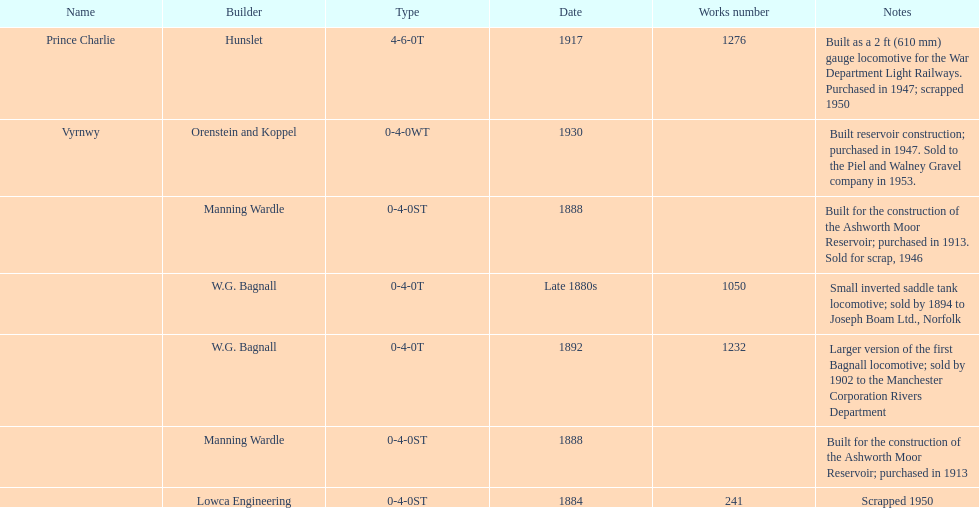How many locomotives were built before the 1900s? 5. 